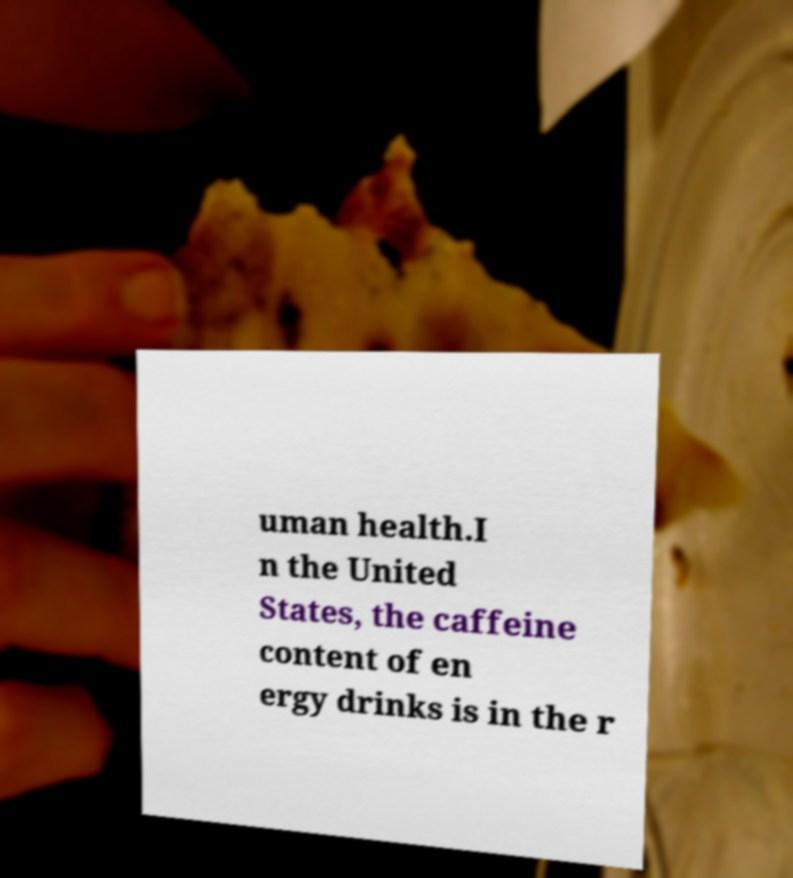I need the written content from this picture converted into text. Can you do that? uman health.I n the United States, the caffeine content of en ergy drinks is in the r 